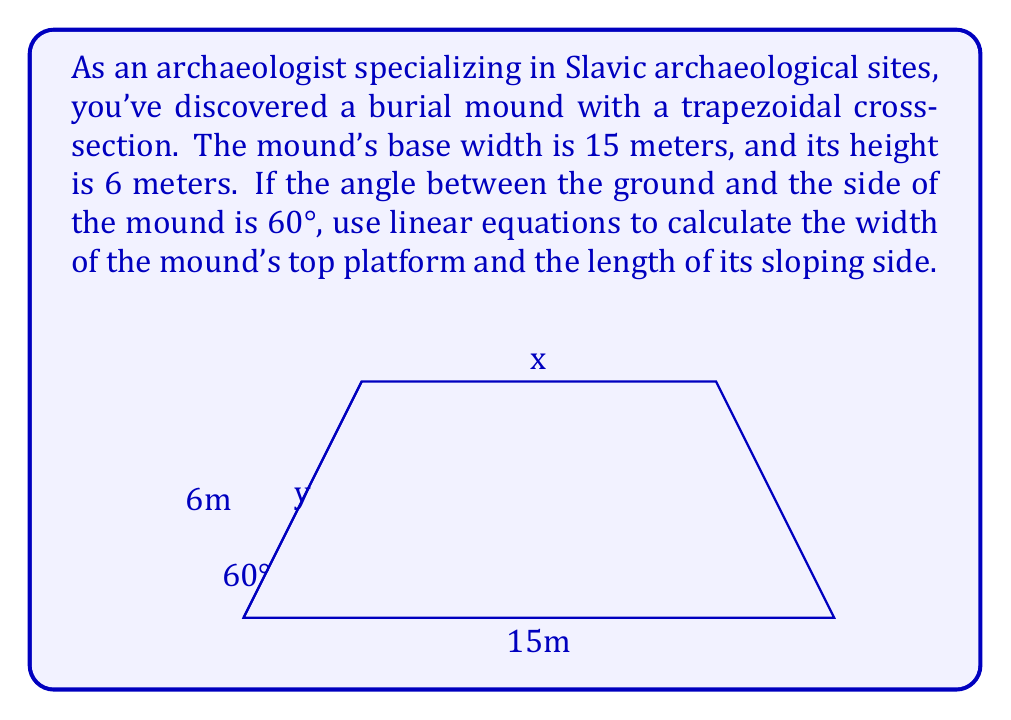Could you help me with this problem? Let's approach this problem step by step:

1) Let $x$ be the width of the top platform and $y$ be the length of the sloping side.

2) In a right triangle formed by the sloping side, half of the difference between the base and top widths, and the height:

   $\tan 60° = \frac{6}{\frac{15-x}{2}}$

3) We know that $\tan 60° = \sqrt{3}$, so:

   $\sqrt{3} = \frac{12}{15-x}$

4) Cross-multiply:
   
   $\sqrt{3}(15-x) = 12$

5) Solve for $x$:
   
   $15\sqrt{3} - x\sqrt{3} = 12$
   $15\sqrt{3} - 12 = x\sqrt{3}$
   $x = \frac{15\sqrt{3} - 12}{\sqrt{3}} = 15 - \frac{12}{\sqrt{3}} \approx 8.08$ meters

6) For the length of the sloping side $y$, we can use the Pythagorean theorem:

   $y^2 = 6^2 + (\frac{15-x}{2})^2$

7) Substitute the value of $x$:

   $y^2 = 6^2 + (\frac{15-8.08}{2})^2$
   $y^2 = 36 + 11.97$
   $y^2 = 47.97$
   $y = \sqrt{47.97} \approx 6.93$ meters

Thus, we have calculated both the width of the top platform and the length of the sloping side.
Answer: The width of the mound's top platform is approximately 8.08 meters, and the length of its sloping side is approximately 6.93 meters. 